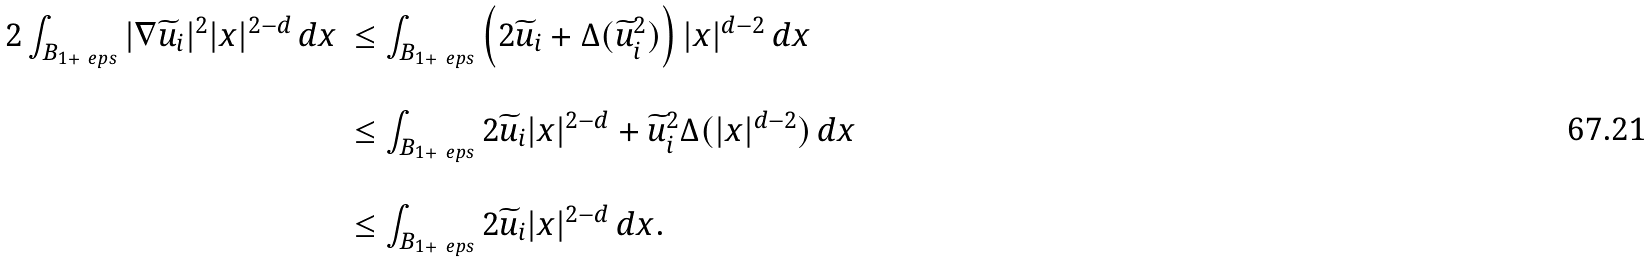<formula> <loc_0><loc_0><loc_500><loc_500>\begin{array} { l l } 2 \int _ { B _ { 1 + \ e p s } } | \nabla \widetilde { u } _ { i } | ^ { 2 } | x | ^ { 2 - d } \, d x & \leq \int _ { B _ { 1 + \ e p s } } \left ( 2 \widetilde { u } _ { i } + \Delta ( \widetilde { u } _ { i } ^ { 2 } ) \right ) | x | ^ { d - 2 } \, d x \\ \\ & \leq \int _ { B _ { 1 + \ e p s } } 2 \widetilde { u } _ { i } | x | ^ { 2 - d } + \widetilde { u } _ { i } ^ { 2 } \Delta ( | x | ^ { d - 2 } ) \, d x \\ \\ & \leq \int _ { B _ { 1 + \ e p s } } 2 \widetilde { u } _ { i } | x | ^ { 2 - d } \, d x . \end{array}</formula> 